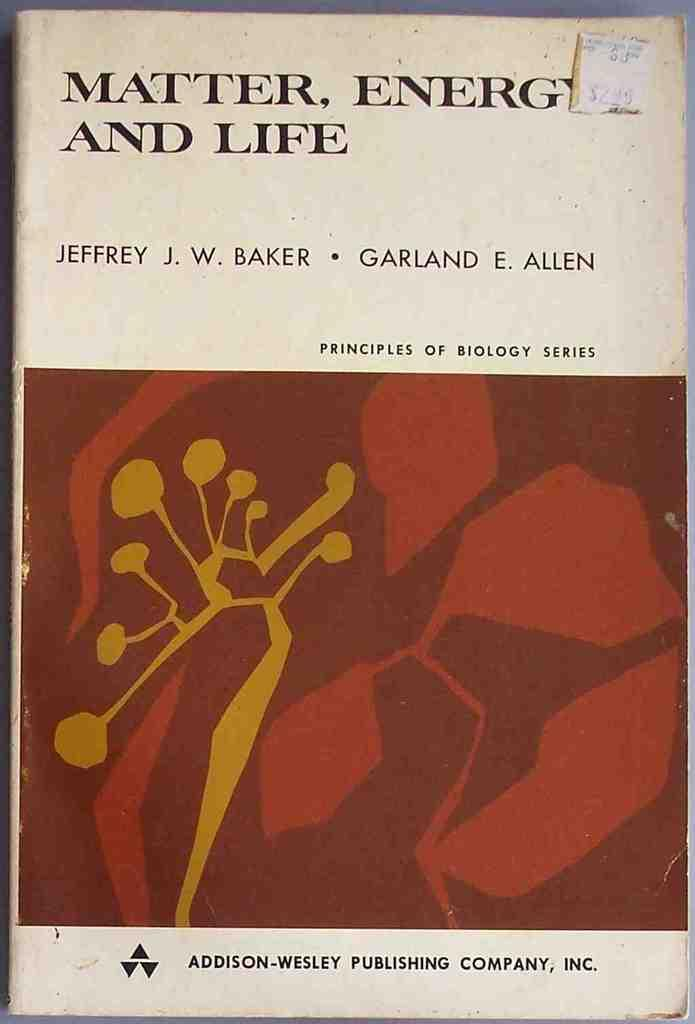<image>
Present a compact description of the photo's key features. The book shown was publihed by Addison-Wesley Publishing Company. 